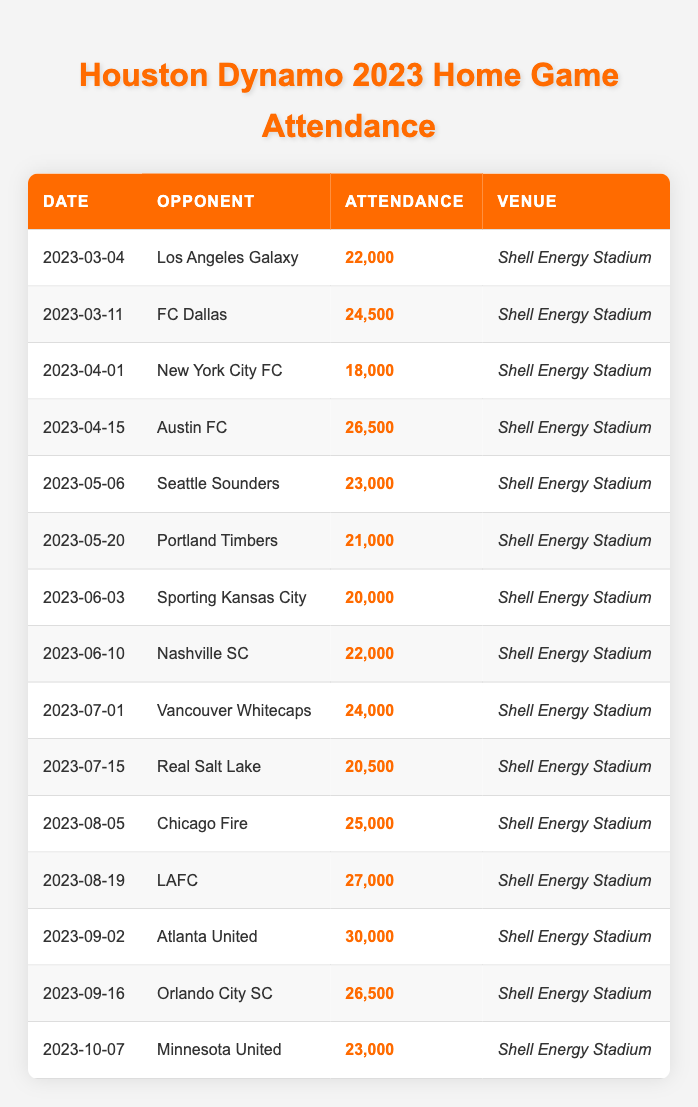What was the highest attendance figure for a Houston Dynamo home game in 2023? Looking through the attendance figures, the highest recorded attendance is 30,000 for the match against Atlanta United on September 2nd.
Answer: 30,000 How many games had an attendance figure over 25,000? By reviewing the attendance numbers, there are 5 games where attendance exceeded 25,000: April 15 (26,500), August 19 (27,000), and September 2 (30,000), plus an additional two games: March 11 (24,500) and August 5 (25,000) which qualifies the count to be 6.
Answer: 6 What was the average attendance for the home games in May? The attendance figures for May are 23,000 and 21,000. Thus, (23,000 + 21,000) / 2 = 22,000 is the average.
Answer: 22,000 Did any game have an attendance of exactly 22,000? There are two instances in the table where attendance was recorded as 22,000: on March 4 and June 10. So, yes, there were games with that attendance.
Answer: Yes What was the total attendance for the games against FC Dallas and LAFC? The attendance for FC Dallas is 24,500 and for LAFC is 27,000. Adding these figures gives 24,500 + 27,000 = 51,500 as the total attendance for those two games.
Answer: 51,500 Which game had the lowest attendance in 2023, and what was that figure? The table shows that the lowest attendance was for the game against New York City FC on April 1, which had 18,000 attendees.
Answer: 18,000 What was the change in attendance from the game against Austin FC to the game against Orlando City SC? The attendance for Austin FC was 26,500 and for Orlando City SC was 26,500. Therefore, the change in attendance is 26,500 - 26,500 = 0, indicating no change.
Answer: 0 How many games had an attendance less than 20,000? Upon examining the table, the only game with an attendance lower than 20,000 was the game against New York City FC, which had 18,000. Thus, there was only one such game.
Answer: 1 What is the average attendance for the matches held in July? The attendance figures for July are 24,000 (Vancouver Whitecaps) and 20,500 (Real Salt Lake). Therefore, (24,000 + 20,500) / 2 = 22,250 becomes the average attendance for July.
Answer: 22,250 Was the attendance for the match against Portland Timbers greater than the attendance for the match against Sporting Kansas City? Checking the figures, the attendance for Portland Timbers was 21,000 and for Sporting Kansas City was 20,000. Thus, 21,000 > 20,000 confirms that the attendance for Portland Timbers was indeed greater.
Answer: Yes 